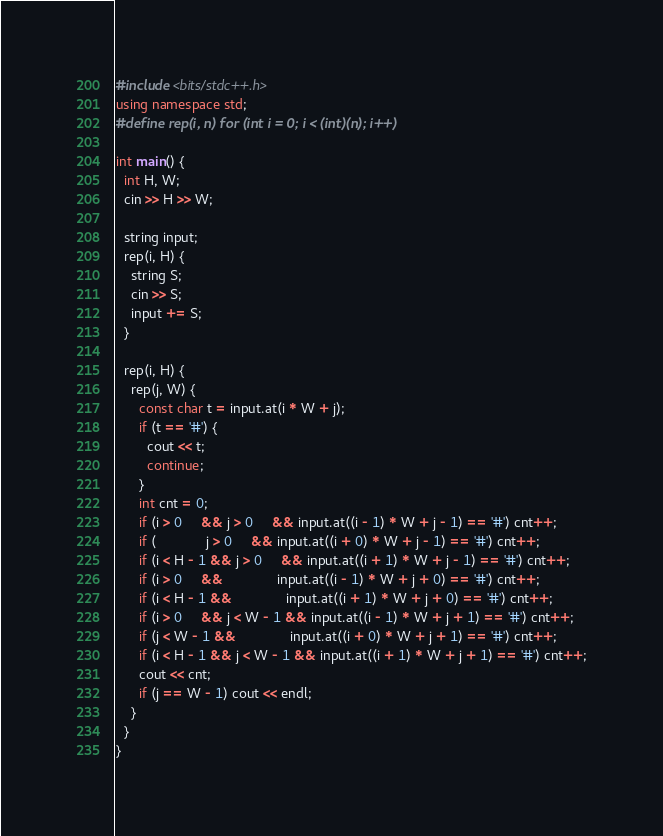Convert code to text. <code><loc_0><loc_0><loc_500><loc_500><_C++_>#include <bits/stdc++.h>
using namespace std;
#define rep(i, n) for (int i = 0; i < (int)(n); i++)

int main() {
  int H, W;
  cin >> H >> W;

  string input;
  rep(i, H) {
    string S;
    cin >> S;
    input += S;
  }

  rep(i, H) {
    rep(j, W) {
      const char t = input.at(i * W + j);
      if (t == '#') {
        cout << t;
        continue;
      }
      int cnt = 0;
      if (i > 0     && j > 0     && input.at((i - 1) * W + j - 1) == '#') cnt++;
      if (             j > 0     && input.at((i + 0) * W + j - 1) == '#') cnt++;
      if (i < H - 1 && j > 0     && input.at((i + 1) * W + j - 1) == '#') cnt++;
      if (i > 0     &&              input.at((i - 1) * W + j + 0) == '#') cnt++;
      if (i < H - 1 &&              input.at((i + 1) * W + j + 0) == '#') cnt++;
      if (i > 0     && j < W - 1 && input.at((i - 1) * W + j + 1) == '#') cnt++;
      if (j < W - 1 &&              input.at((i + 0) * W + j + 1) == '#') cnt++;
      if (i < H - 1 && j < W - 1 && input.at((i + 1) * W + j + 1) == '#') cnt++;
      cout << cnt;
      if (j == W - 1) cout << endl;
    }
  }
}

</code> 